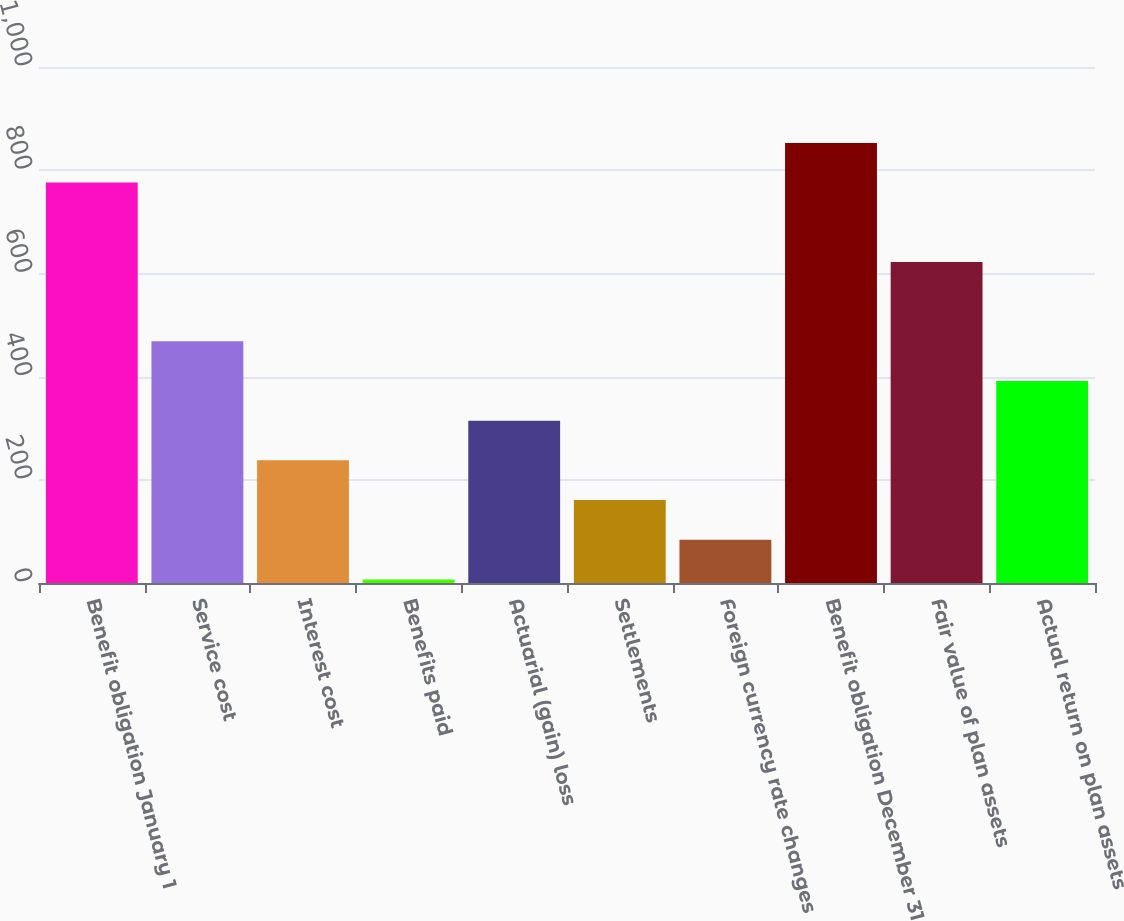Convert chart to OTSL. <chart><loc_0><loc_0><loc_500><loc_500><bar_chart><fcel>Benefit obligation January 1<fcel>Service cost<fcel>Interest cost<fcel>Benefits paid<fcel>Actuarial (gain) loss<fcel>Settlements<fcel>Foreign currency rate changes<fcel>Benefit obligation December 31<fcel>Fair value of plan assets<fcel>Actual return on plan assets<nl><fcel>776<fcel>468.4<fcel>237.7<fcel>7<fcel>314.6<fcel>160.8<fcel>83.9<fcel>852.9<fcel>622.2<fcel>391.5<nl></chart> 